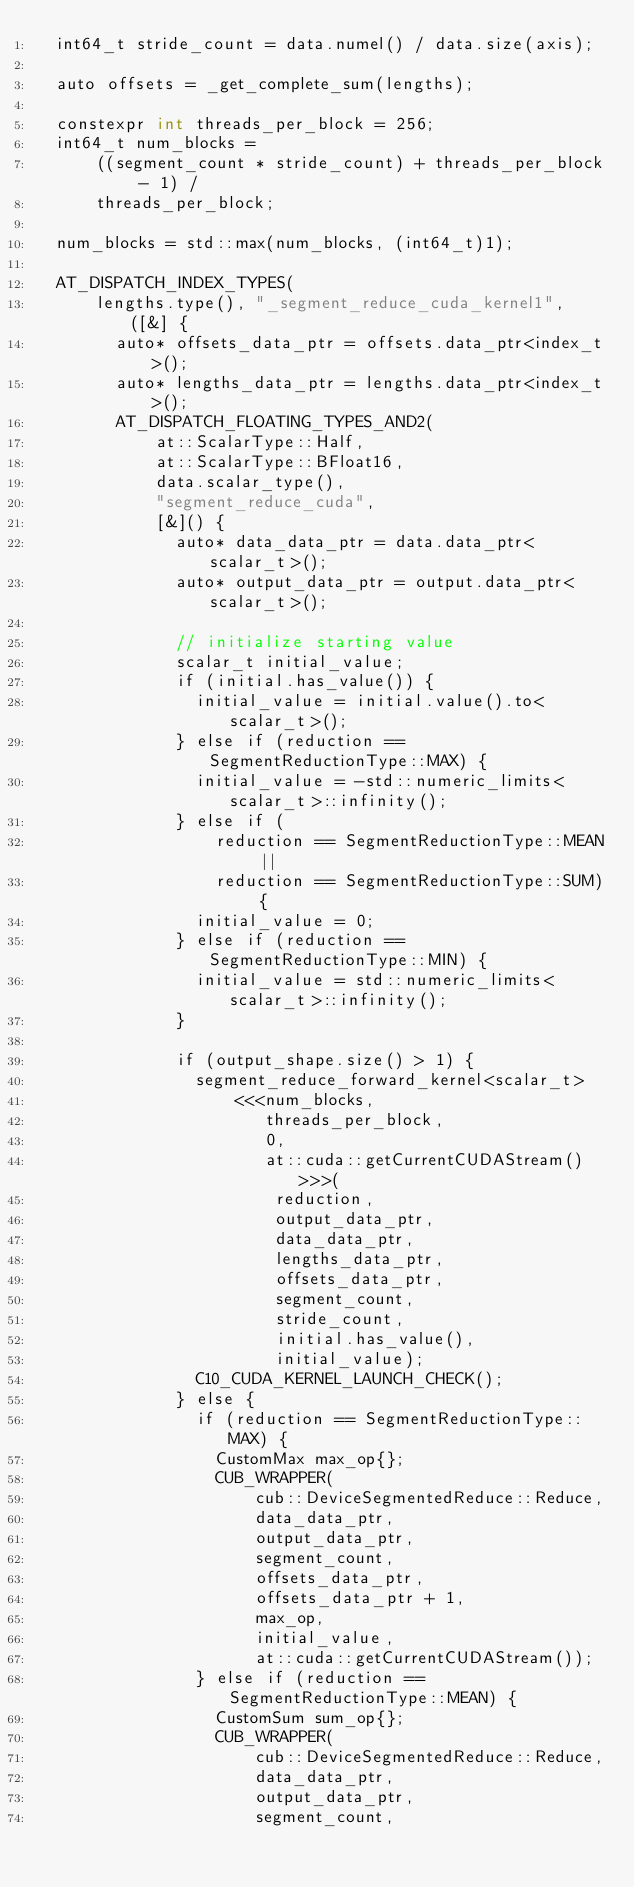<code> <loc_0><loc_0><loc_500><loc_500><_Cuda_>  int64_t stride_count = data.numel() / data.size(axis);

  auto offsets = _get_complete_sum(lengths);

  constexpr int threads_per_block = 256;
  int64_t num_blocks =
      ((segment_count * stride_count) + threads_per_block - 1) /
      threads_per_block;

  num_blocks = std::max(num_blocks, (int64_t)1);

  AT_DISPATCH_INDEX_TYPES(
      lengths.type(), "_segment_reduce_cuda_kernel1", ([&] {
        auto* offsets_data_ptr = offsets.data_ptr<index_t>();
        auto* lengths_data_ptr = lengths.data_ptr<index_t>();
        AT_DISPATCH_FLOATING_TYPES_AND2(
            at::ScalarType::Half,
            at::ScalarType::BFloat16,
            data.scalar_type(),
            "segment_reduce_cuda",
            [&]() {
              auto* data_data_ptr = data.data_ptr<scalar_t>();
              auto* output_data_ptr = output.data_ptr<scalar_t>();

              // initialize starting value
              scalar_t initial_value;
              if (initial.has_value()) {
                initial_value = initial.value().to<scalar_t>();
              } else if (reduction == SegmentReductionType::MAX) {
                initial_value = -std::numeric_limits<scalar_t>::infinity();
              } else if (
                  reduction == SegmentReductionType::MEAN ||
                  reduction == SegmentReductionType::SUM) {
                initial_value = 0;
              } else if (reduction == SegmentReductionType::MIN) {
                initial_value = std::numeric_limits<scalar_t>::infinity();
              }

              if (output_shape.size() > 1) {
                segment_reduce_forward_kernel<scalar_t>
                    <<<num_blocks,
                       threads_per_block,
                       0,
                       at::cuda::getCurrentCUDAStream()>>>(
                        reduction,
                        output_data_ptr,
                        data_data_ptr,
                        lengths_data_ptr,
                        offsets_data_ptr,
                        segment_count,
                        stride_count,
                        initial.has_value(),
                        initial_value);
                C10_CUDA_KERNEL_LAUNCH_CHECK();
              } else {
                if (reduction == SegmentReductionType::MAX) {
                  CustomMax max_op{};
                  CUB_WRAPPER(
                      cub::DeviceSegmentedReduce::Reduce,
                      data_data_ptr,
                      output_data_ptr,
                      segment_count,
                      offsets_data_ptr,
                      offsets_data_ptr + 1,
                      max_op,
                      initial_value,
                      at::cuda::getCurrentCUDAStream());
                } else if (reduction == SegmentReductionType::MEAN) {
                  CustomSum sum_op{};
                  CUB_WRAPPER(
                      cub::DeviceSegmentedReduce::Reduce,
                      data_data_ptr,
                      output_data_ptr,
                      segment_count,</code> 